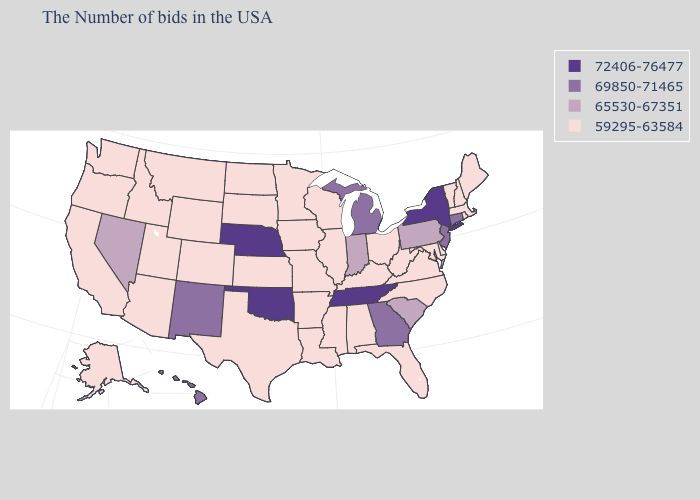What is the highest value in the USA?
Answer briefly. 72406-76477. Does Michigan have the lowest value in the MidWest?
Concise answer only. No. Among the states that border Texas , which have the lowest value?
Be succinct. Louisiana, Arkansas. Name the states that have a value in the range 65530-67351?
Short answer required. Pennsylvania, South Carolina, Indiana, Nevada. Name the states that have a value in the range 72406-76477?
Keep it brief. New York, Tennessee, Nebraska, Oklahoma. Name the states that have a value in the range 69850-71465?
Write a very short answer. Connecticut, New Jersey, Georgia, Michigan, New Mexico, Hawaii. What is the value of Colorado?
Be succinct. 59295-63584. Among the states that border Florida , does Alabama have the highest value?
Give a very brief answer. No. Among the states that border Florida , does Georgia have the highest value?
Answer briefly. Yes. Does Rhode Island have the same value as Michigan?
Keep it brief. No. Which states hav the highest value in the MidWest?
Give a very brief answer. Nebraska. What is the lowest value in the Northeast?
Give a very brief answer. 59295-63584. What is the lowest value in the MidWest?
Be succinct. 59295-63584. Which states have the highest value in the USA?
Give a very brief answer. New York, Tennessee, Nebraska, Oklahoma. 